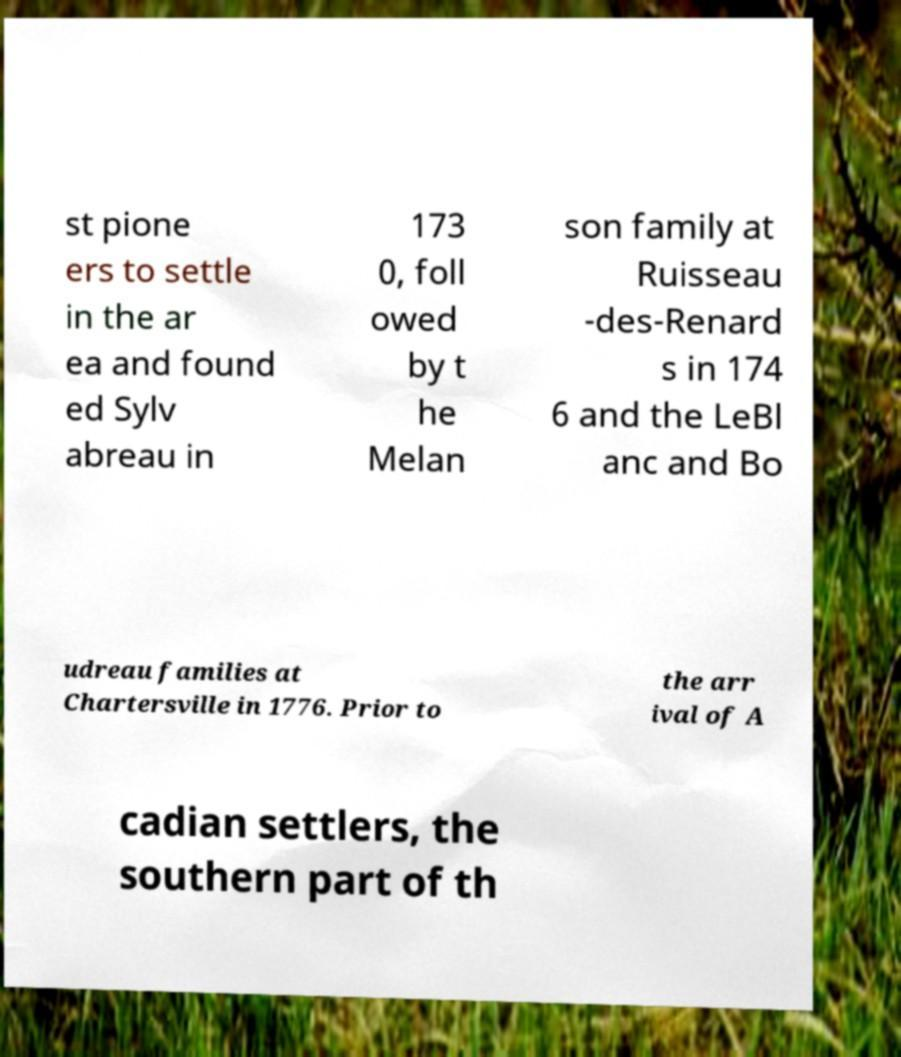Could you assist in decoding the text presented in this image and type it out clearly? st pione ers to settle in the ar ea and found ed Sylv abreau in 173 0, foll owed by t he Melan son family at Ruisseau -des-Renard s in 174 6 and the LeBl anc and Bo udreau families at Chartersville in 1776. Prior to the arr ival of A cadian settlers, the southern part of th 